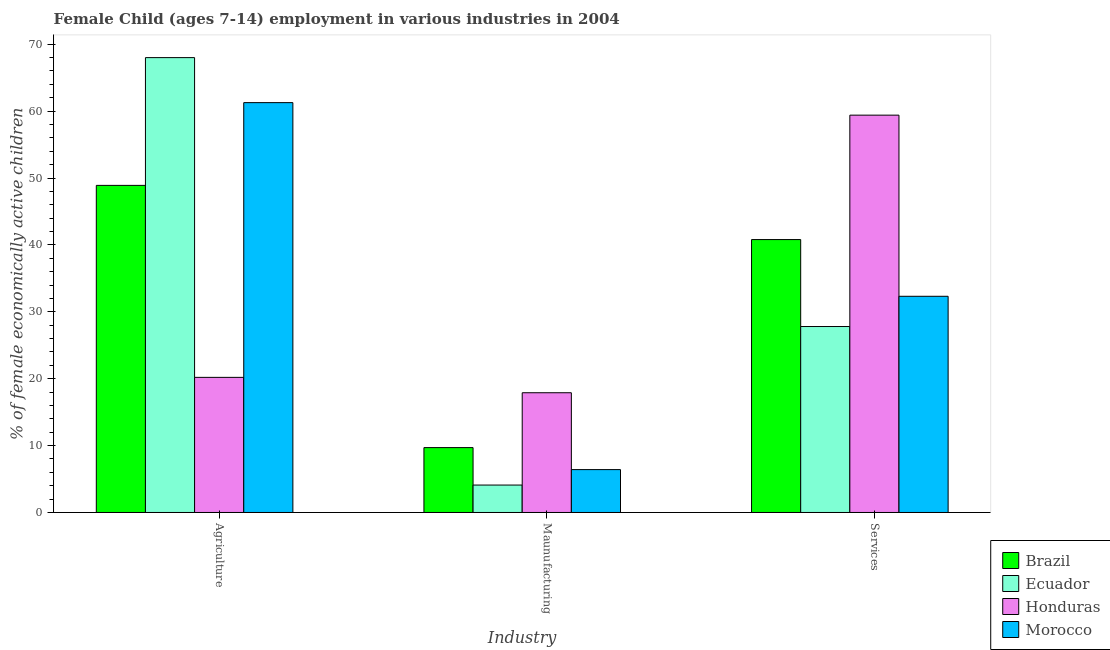Are the number of bars per tick equal to the number of legend labels?
Provide a succinct answer. Yes. How many bars are there on the 3rd tick from the left?
Your answer should be compact. 4. How many bars are there on the 1st tick from the right?
Ensure brevity in your answer.  4. What is the label of the 1st group of bars from the left?
Make the answer very short. Agriculture. What is the percentage of economically active children in services in Honduras?
Your response must be concise. 59.4. Across all countries, what is the maximum percentage of economically active children in manufacturing?
Your answer should be very brief. 17.9. In which country was the percentage of economically active children in agriculture maximum?
Offer a very short reply. Ecuador. In which country was the percentage of economically active children in agriculture minimum?
Keep it short and to the point. Honduras. What is the total percentage of economically active children in manufacturing in the graph?
Provide a short and direct response. 38.11. What is the difference between the percentage of economically active children in agriculture in Honduras and that in Brazil?
Your answer should be compact. -28.7. What is the difference between the percentage of economically active children in agriculture in Ecuador and the percentage of economically active children in services in Morocco?
Your response must be concise. 35.68. What is the average percentage of economically active children in services per country?
Keep it short and to the point. 40.08. What is the difference between the percentage of economically active children in manufacturing and percentage of economically active children in agriculture in Brazil?
Provide a short and direct response. -39.2. What is the ratio of the percentage of economically active children in manufacturing in Brazil to that in Morocco?
Your answer should be very brief. 1.51. What is the difference between the highest and the lowest percentage of economically active children in agriculture?
Provide a short and direct response. 47.8. What does the 3rd bar from the left in Agriculture represents?
Offer a very short reply. Honduras. What does the 4th bar from the right in Agriculture represents?
Your answer should be compact. Brazil. Is it the case that in every country, the sum of the percentage of economically active children in agriculture and percentage of economically active children in manufacturing is greater than the percentage of economically active children in services?
Your answer should be compact. No. Are all the bars in the graph horizontal?
Give a very brief answer. No. Does the graph contain any zero values?
Make the answer very short. No. Does the graph contain grids?
Offer a terse response. No. What is the title of the graph?
Keep it short and to the point. Female Child (ages 7-14) employment in various industries in 2004. What is the label or title of the X-axis?
Offer a terse response. Industry. What is the label or title of the Y-axis?
Ensure brevity in your answer.  % of female economically active children. What is the % of female economically active children in Brazil in Agriculture?
Provide a short and direct response. 48.9. What is the % of female economically active children of Honduras in Agriculture?
Keep it short and to the point. 20.2. What is the % of female economically active children in Morocco in Agriculture?
Your answer should be compact. 61.27. What is the % of female economically active children of Brazil in Maunufacturing?
Make the answer very short. 9.7. What is the % of female economically active children of Ecuador in Maunufacturing?
Make the answer very short. 4.1. What is the % of female economically active children in Morocco in Maunufacturing?
Keep it short and to the point. 6.41. What is the % of female economically active children in Brazil in Services?
Your answer should be compact. 40.8. What is the % of female economically active children in Ecuador in Services?
Your response must be concise. 27.8. What is the % of female economically active children of Honduras in Services?
Your response must be concise. 59.4. What is the % of female economically active children of Morocco in Services?
Keep it short and to the point. 32.32. Across all Industry, what is the maximum % of female economically active children in Brazil?
Give a very brief answer. 48.9. Across all Industry, what is the maximum % of female economically active children in Honduras?
Your answer should be very brief. 59.4. Across all Industry, what is the maximum % of female economically active children in Morocco?
Your response must be concise. 61.27. Across all Industry, what is the minimum % of female economically active children in Brazil?
Make the answer very short. 9.7. Across all Industry, what is the minimum % of female economically active children of Ecuador?
Keep it short and to the point. 4.1. Across all Industry, what is the minimum % of female economically active children of Morocco?
Keep it short and to the point. 6.41. What is the total % of female economically active children of Brazil in the graph?
Your answer should be very brief. 99.4. What is the total % of female economically active children in Ecuador in the graph?
Provide a succinct answer. 99.9. What is the total % of female economically active children of Honduras in the graph?
Keep it short and to the point. 97.5. What is the total % of female economically active children of Morocco in the graph?
Your response must be concise. 100. What is the difference between the % of female economically active children in Brazil in Agriculture and that in Maunufacturing?
Your answer should be very brief. 39.2. What is the difference between the % of female economically active children of Ecuador in Agriculture and that in Maunufacturing?
Provide a succinct answer. 63.9. What is the difference between the % of female economically active children of Honduras in Agriculture and that in Maunufacturing?
Offer a very short reply. 2.3. What is the difference between the % of female economically active children of Morocco in Agriculture and that in Maunufacturing?
Keep it short and to the point. 54.86. What is the difference between the % of female economically active children of Brazil in Agriculture and that in Services?
Provide a short and direct response. 8.1. What is the difference between the % of female economically active children of Ecuador in Agriculture and that in Services?
Make the answer very short. 40.2. What is the difference between the % of female economically active children of Honduras in Agriculture and that in Services?
Offer a terse response. -39.2. What is the difference between the % of female economically active children in Morocco in Agriculture and that in Services?
Ensure brevity in your answer.  28.95. What is the difference between the % of female economically active children of Brazil in Maunufacturing and that in Services?
Your answer should be compact. -31.1. What is the difference between the % of female economically active children of Ecuador in Maunufacturing and that in Services?
Make the answer very short. -23.7. What is the difference between the % of female economically active children of Honduras in Maunufacturing and that in Services?
Provide a succinct answer. -41.5. What is the difference between the % of female economically active children of Morocco in Maunufacturing and that in Services?
Keep it short and to the point. -25.91. What is the difference between the % of female economically active children in Brazil in Agriculture and the % of female economically active children in Ecuador in Maunufacturing?
Give a very brief answer. 44.8. What is the difference between the % of female economically active children of Brazil in Agriculture and the % of female economically active children of Morocco in Maunufacturing?
Ensure brevity in your answer.  42.49. What is the difference between the % of female economically active children of Ecuador in Agriculture and the % of female economically active children of Honduras in Maunufacturing?
Your response must be concise. 50.1. What is the difference between the % of female economically active children in Ecuador in Agriculture and the % of female economically active children in Morocco in Maunufacturing?
Your response must be concise. 61.59. What is the difference between the % of female economically active children in Honduras in Agriculture and the % of female economically active children in Morocco in Maunufacturing?
Provide a succinct answer. 13.79. What is the difference between the % of female economically active children in Brazil in Agriculture and the % of female economically active children in Ecuador in Services?
Your response must be concise. 21.1. What is the difference between the % of female economically active children in Brazil in Agriculture and the % of female economically active children in Morocco in Services?
Provide a succinct answer. 16.58. What is the difference between the % of female economically active children in Ecuador in Agriculture and the % of female economically active children in Honduras in Services?
Your answer should be compact. 8.6. What is the difference between the % of female economically active children of Ecuador in Agriculture and the % of female economically active children of Morocco in Services?
Your response must be concise. 35.68. What is the difference between the % of female economically active children in Honduras in Agriculture and the % of female economically active children in Morocco in Services?
Offer a terse response. -12.12. What is the difference between the % of female economically active children in Brazil in Maunufacturing and the % of female economically active children in Ecuador in Services?
Offer a terse response. -18.1. What is the difference between the % of female economically active children of Brazil in Maunufacturing and the % of female economically active children of Honduras in Services?
Give a very brief answer. -49.7. What is the difference between the % of female economically active children of Brazil in Maunufacturing and the % of female economically active children of Morocco in Services?
Offer a terse response. -22.62. What is the difference between the % of female economically active children of Ecuador in Maunufacturing and the % of female economically active children of Honduras in Services?
Your answer should be very brief. -55.3. What is the difference between the % of female economically active children in Ecuador in Maunufacturing and the % of female economically active children in Morocco in Services?
Ensure brevity in your answer.  -28.22. What is the difference between the % of female economically active children in Honduras in Maunufacturing and the % of female economically active children in Morocco in Services?
Provide a short and direct response. -14.42. What is the average % of female economically active children in Brazil per Industry?
Make the answer very short. 33.13. What is the average % of female economically active children in Ecuador per Industry?
Make the answer very short. 33.3. What is the average % of female economically active children of Honduras per Industry?
Your answer should be very brief. 32.5. What is the average % of female economically active children of Morocco per Industry?
Keep it short and to the point. 33.33. What is the difference between the % of female economically active children in Brazil and % of female economically active children in Ecuador in Agriculture?
Give a very brief answer. -19.1. What is the difference between the % of female economically active children in Brazil and % of female economically active children in Honduras in Agriculture?
Your answer should be compact. 28.7. What is the difference between the % of female economically active children in Brazil and % of female economically active children in Morocco in Agriculture?
Provide a short and direct response. -12.37. What is the difference between the % of female economically active children of Ecuador and % of female economically active children of Honduras in Agriculture?
Offer a terse response. 47.8. What is the difference between the % of female economically active children in Ecuador and % of female economically active children in Morocco in Agriculture?
Give a very brief answer. 6.73. What is the difference between the % of female economically active children in Honduras and % of female economically active children in Morocco in Agriculture?
Make the answer very short. -41.07. What is the difference between the % of female economically active children in Brazil and % of female economically active children in Ecuador in Maunufacturing?
Your answer should be compact. 5.6. What is the difference between the % of female economically active children in Brazil and % of female economically active children in Morocco in Maunufacturing?
Offer a terse response. 3.29. What is the difference between the % of female economically active children of Ecuador and % of female economically active children of Honduras in Maunufacturing?
Offer a terse response. -13.8. What is the difference between the % of female economically active children in Ecuador and % of female economically active children in Morocco in Maunufacturing?
Offer a very short reply. -2.31. What is the difference between the % of female economically active children of Honduras and % of female economically active children of Morocco in Maunufacturing?
Offer a terse response. 11.49. What is the difference between the % of female economically active children of Brazil and % of female economically active children of Honduras in Services?
Offer a very short reply. -18.6. What is the difference between the % of female economically active children of Brazil and % of female economically active children of Morocco in Services?
Your response must be concise. 8.48. What is the difference between the % of female economically active children of Ecuador and % of female economically active children of Honduras in Services?
Provide a succinct answer. -31.6. What is the difference between the % of female economically active children in Ecuador and % of female economically active children in Morocco in Services?
Provide a short and direct response. -4.52. What is the difference between the % of female economically active children of Honduras and % of female economically active children of Morocco in Services?
Provide a succinct answer. 27.08. What is the ratio of the % of female economically active children in Brazil in Agriculture to that in Maunufacturing?
Offer a very short reply. 5.04. What is the ratio of the % of female economically active children in Ecuador in Agriculture to that in Maunufacturing?
Your answer should be very brief. 16.59. What is the ratio of the % of female economically active children of Honduras in Agriculture to that in Maunufacturing?
Your response must be concise. 1.13. What is the ratio of the % of female economically active children of Morocco in Agriculture to that in Maunufacturing?
Make the answer very short. 9.56. What is the ratio of the % of female economically active children in Brazil in Agriculture to that in Services?
Your answer should be very brief. 1.2. What is the ratio of the % of female economically active children of Ecuador in Agriculture to that in Services?
Ensure brevity in your answer.  2.45. What is the ratio of the % of female economically active children of Honduras in Agriculture to that in Services?
Ensure brevity in your answer.  0.34. What is the ratio of the % of female economically active children of Morocco in Agriculture to that in Services?
Your answer should be compact. 1.9. What is the ratio of the % of female economically active children of Brazil in Maunufacturing to that in Services?
Offer a terse response. 0.24. What is the ratio of the % of female economically active children in Ecuador in Maunufacturing to that in Services?
Offer a very short reply. 0.15. What is the ratio of the % of female economically active children in Honduras in Maunufacturing to that in Services?
Provide a short and direct response. 0.3. What is the ratio of the % of female economically active children in Morocco in Maunufacturing to that in Services?
Your response must be concise. 0.2. What is the difference between the highest and the second highest % of female economically active children of Ecuador?
Offer a terse response. 40.2. What is the difference between the highest and the second highest % of female economically active children in Honduras?
Keep it short and to the point. 39.2. What is the difference between the highest and the second highest % of female economically active children of Morocco?
Provide a short and direct response. 28.95. What is the difference between the highest and the lowest % of female economically active children of Brazil?
Your answer should be very brief. 39.2. What is the difference between the highest and the lowest % of female economically active children of Ecuador?
Provide a succinct answer. 63.9. What is the difference between the highest and the lowest % of female economically active children of Honduras?
Your response must be concise. 41.5. What is the difference between the highest and the lowest % of female economically active children in Morocco?
Your answer should be compact. 54.86. 